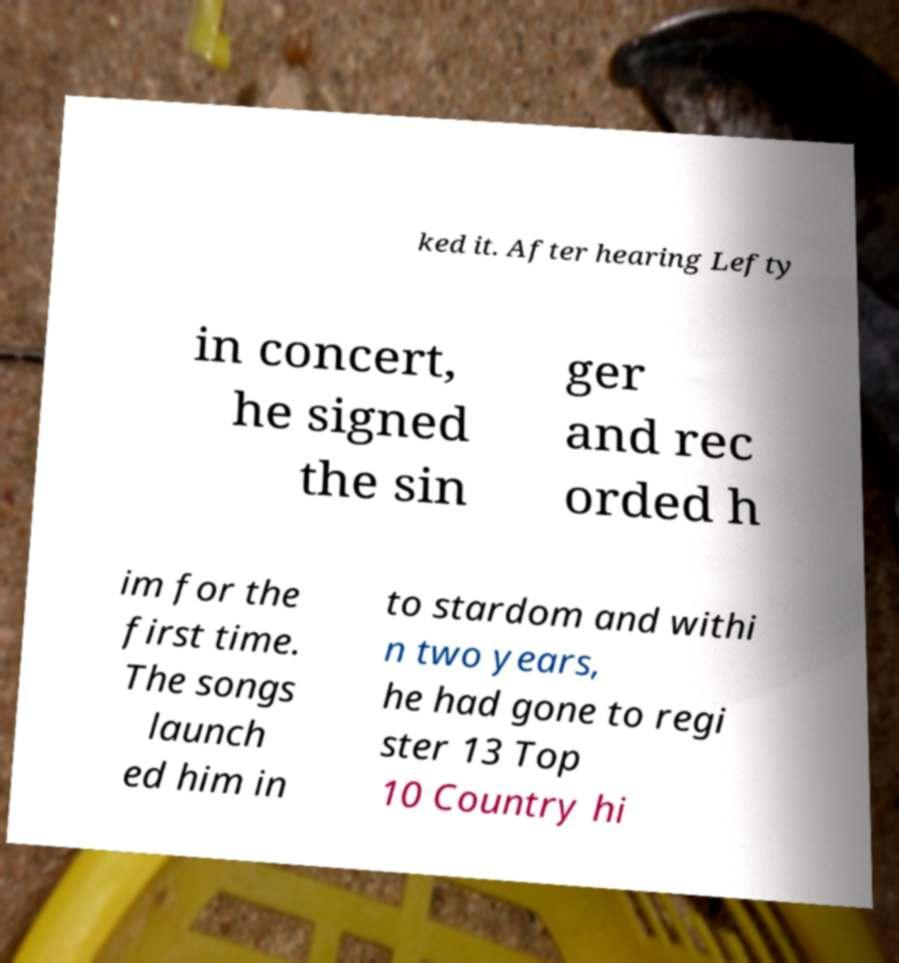Could you assist in decoding the text presented in this image and type it out clearly? ked it. After hearing Lefty in concert, he signed the sin ger and rec orded h im for the first time. The songs launch ed him in to stardom and withi n two years, he had gone to regi ster 13 Top 10 Country hi 